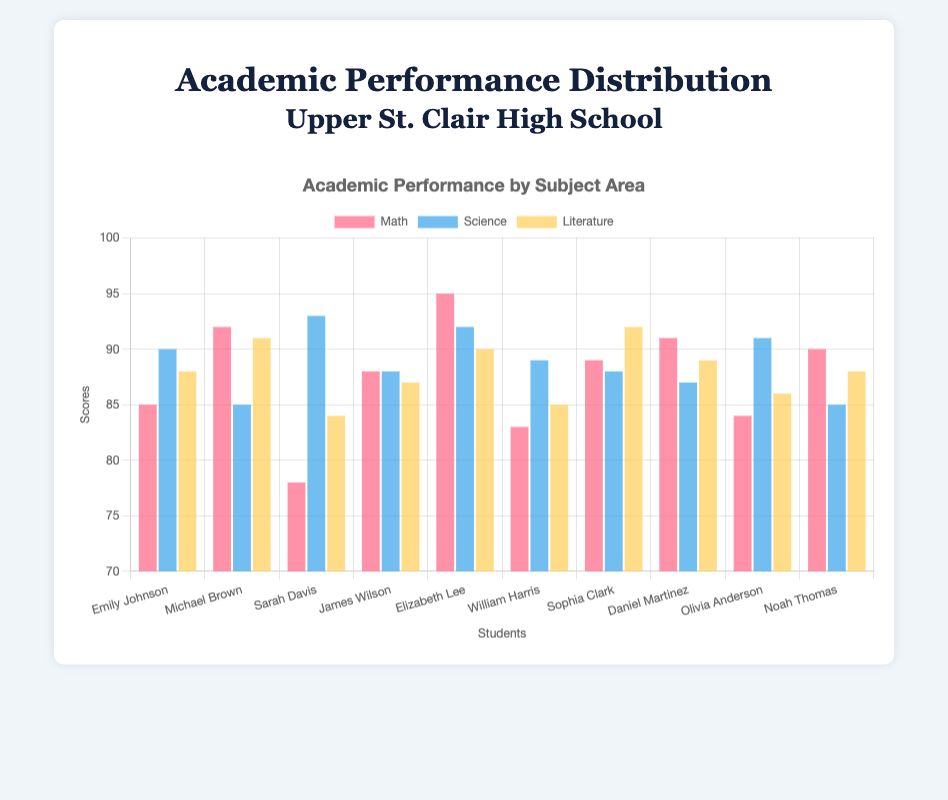What's the highest score in the Math subject and who achieved it? Look for the tallest red bar in the Math dataset and identify the student. The tallest red bar corresponds to Emily Johnson.
Answer: Emily Johnson, 95 Which student has the lowest Science score? Find the shortest blue bar in the Science dataset. The shortest blue bar corresponds to Michael Brown and Noah Thomas.
Answer: Michael Brown, 85 and Noah Thomas, 85 Compare the Literature scores of the top performers in Science. Who scored higher, Elizabeth Lee or Sarah Davis? Look at the Literature scores of Elizabeth Lee and Sarah Davis. Elizabeth Lee has a Literature score of 90 while Sarah Davis has 84.
Answer: Elizabeth Lee What is the average score in Math? Add all the Math scores and divide by the number of students. (85 + 92 + 78 + 88 + 95 + 83 + 89 + 91 + 84 + 90) = 875. Divide by 10.
Answer: 87.5 Who scored consistently above 85 in all subjects? Check each student's Math, Science, and Literature scores to see who has above 85 in all three categories. James Wilson (88, 88, 87), Elizabeth Lee (95, 92, 90), Sophia Clark (89, 88, 92), Daniel Martinez (91, 87, 89), and Noah Thomas (90, 85, 88) scored above 85 in all subjects.
Answer: James Wilson, Elizabeth Lee, Sophia Clark, Daniel Martinez, Noah Thomas Which subject has the highest average score? Calculate the average for each subject.  Math: (85+92+78+88+95+83+89+91+84+90)/10 = 87.5, Science: (90+85+93+88+92+89+88+87+91+85)/10 = 88.8, Literature: (88+91+84+87+90+85+92+89+86+88)/10 = 88.
Answer: Science, 88.8 Across all students, which subject shows the most varied performance between the highest and lowest scores? Determine the range by finding the difference between the highest and lowest scores for each subject. Math: 95 - 78 = 17, Science: 93 - 85 = 8, Literature: 92 - 84 = 8.
Answer: Math, 17 What is Emily Johnson's total score across all subjects? Sum Emily Johnson's scores in Math, Science, and Literature. (85 + 90 + 88)
Answer: 263 Between Daniel Martinez and William Harris, who has a higher cumulative score? Sum the Math, Science, and Literature scores for each student and compare. Daniel Martinez: (91 + 87 + 89) = 267, William Harris: (83 + 89 + 85) = 257.
Answer: Daniel Martinez 